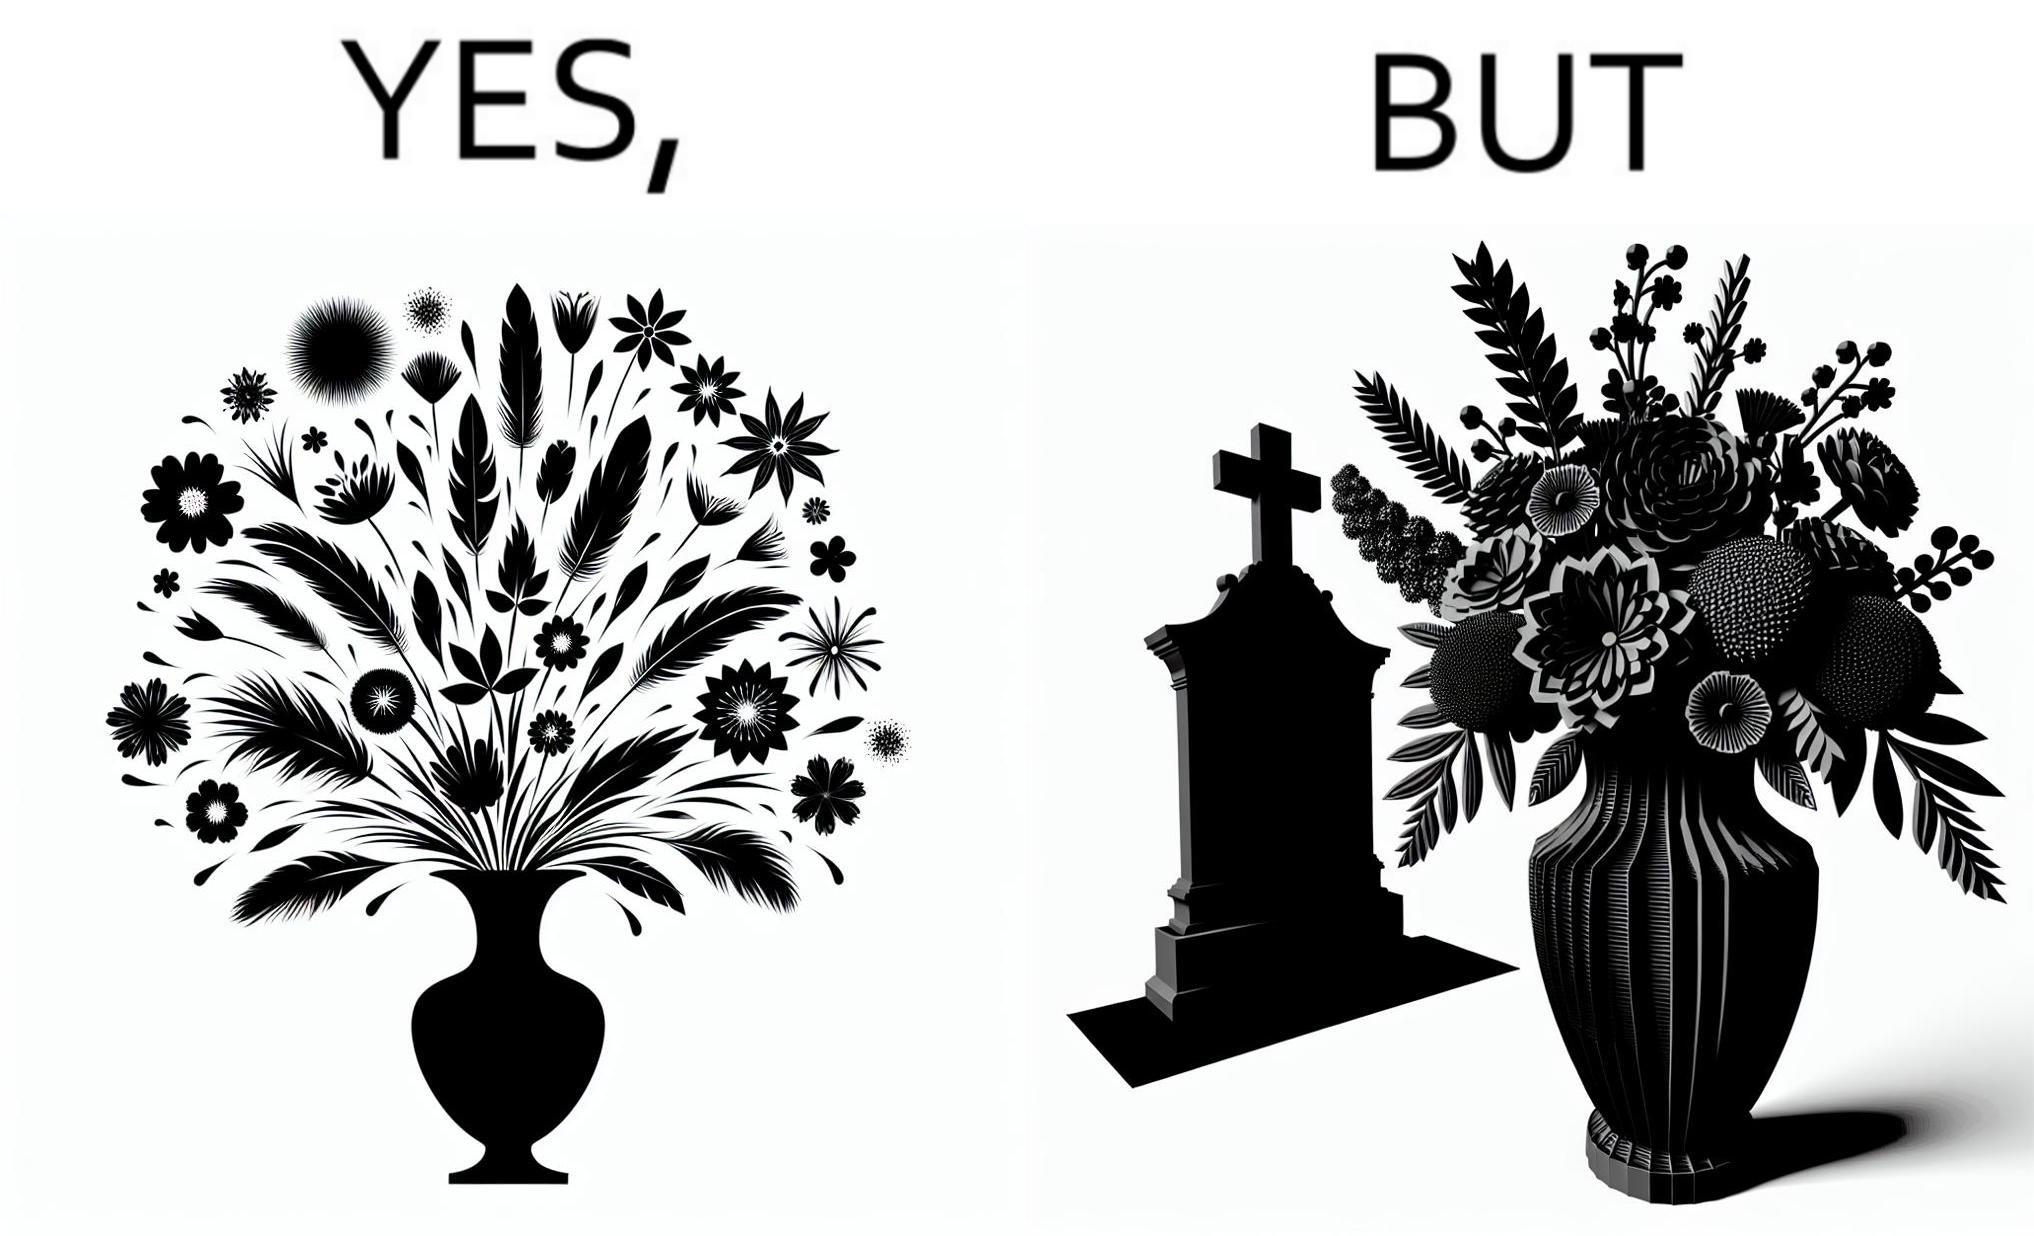What does this image depict? The image is ironic, because in the first image a vase full of different beautiful flowers is seen which spreads a feeling of positivity, cheerfulness etc., whereas in the second image when the same vase is put in front of a grave stone it produces a feeling of sorrow 